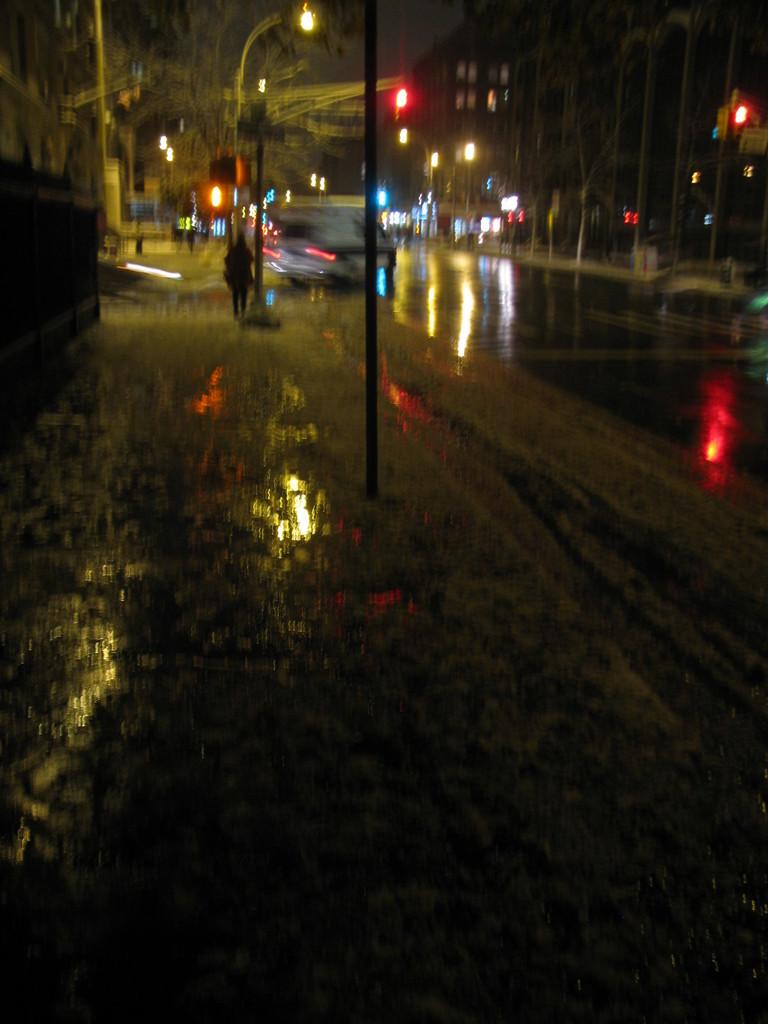What is on the road in the image? There is water on the road in the image. What can be seen supporting the lights in the image? There are poles in the image. What is illuminating the area in the image? There are lights in the image. What type of structure can be seen in the image? There is at least one building in the image. What type of vegetation is present in the image? There are trees in the image. Where is the recess located in the image? There is no recess present in the image. What type of trail can be seen in the image? There is no trail present in the image. 